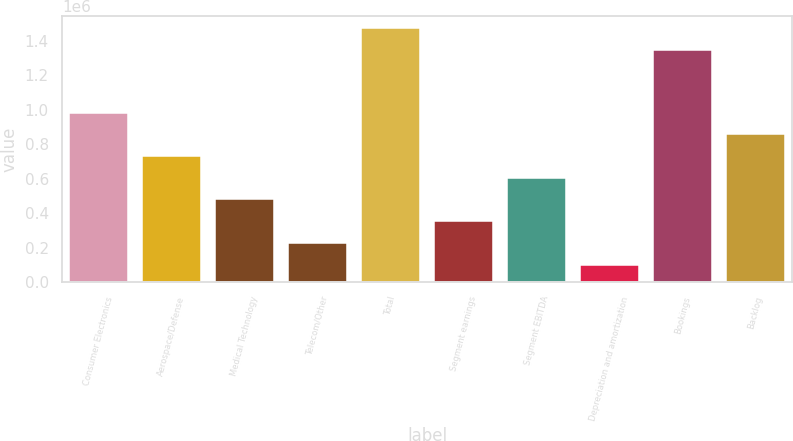<chart> <loc_0><loc_0><loc_500><loc_500><bar_chart><fcel>Consumer Electronics<fcel>Aerospace/Defense<fcel>Medical Technology<fcel>Telecom/Other<fcel>Total<fcel>Segment earnings<fcel>Segment EBITDA<fcel>Depreciation and amortization<fcel>Bookings<fcel>Backlog<nl><fcel>982606<fcel>730958<fcel>479310<fcel>227663<fcel>1.47036e+06<fcel>353487<fcel>605134<fcel>101839<fcel>1.34454e+06<fcel>856782<nl></chart> 